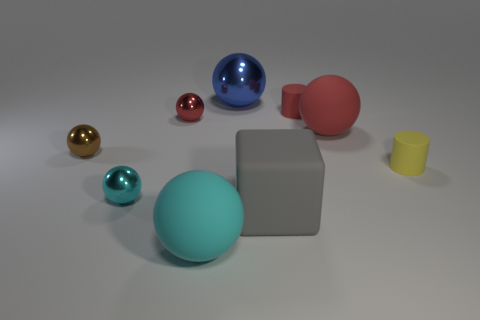Subtract 3 balls. How many balls are left? 3 Subtract all brown balls. How many balls are left? 5 Subtract all tiny brown shiny spheres. How many spheres are left? 5 Subtract all purple balls. Subtract all red blocks. How many balls are left? 6 Subtract all balls. How many objects are left? 3 Subtract all tiny cyan shiny spheres. Subtract all balls. How many objects are left? 2 Add 5 small yellow cylinders. How many small yellow cylinders are left? 6 Add 4 small cyan things. How many small cyan things exist? 5 Subtract 1 gray blocks. How many objects are left? 8 